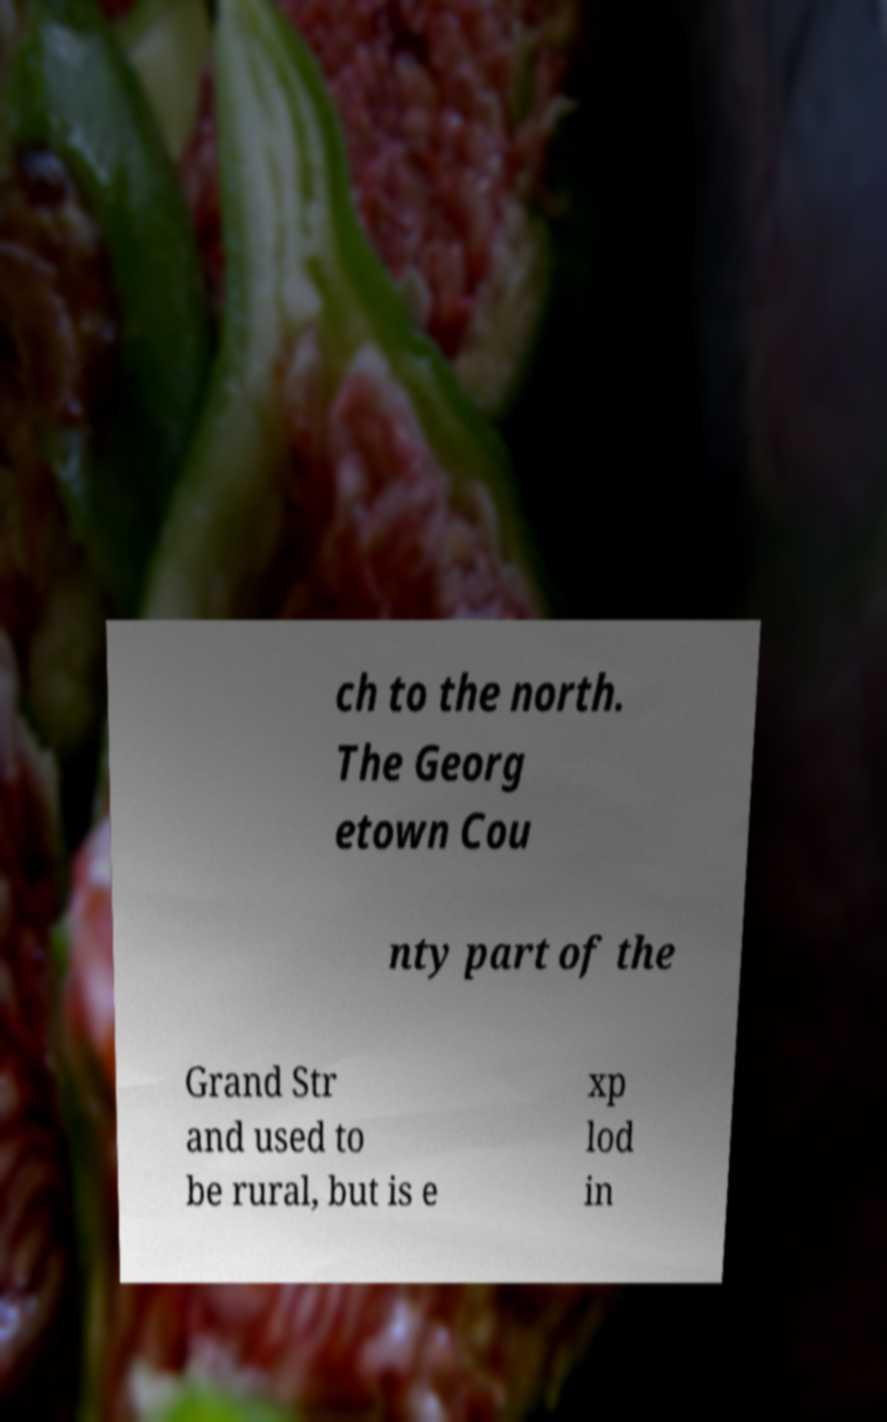Can you read and provide the text displayed in the image?This photo seems to have some interesting text. Can you extract and type it out for me? ch to the north. The Georg etown Cou nty part of the Grand Str and used to be rural, but is e xp lod in 